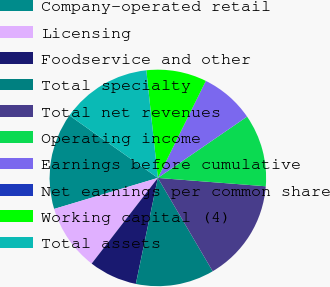<chart> <loc_0><loc_0><loc_500><loc_500><pie_chart><fcel>Company-operated retail<fcel>Licensing<fcel>Foodservice and other<fcel>Total specialty<fcel>Total net revenues<fcel>Operating income<fcel>Earnings before cumulative<fcel>Net earnings per common share<fcel>Working capital (4)<fcel>Total assets<nl><fcel>14.41%<fcel>9.91%<fcel>7.21%<fcel>11.71%<fcel>15.32%<fcel>10.81%<fcel>8.11%<fcel>0.0%<fcel>9.01%<fcel>13.51%<nl></chart> 